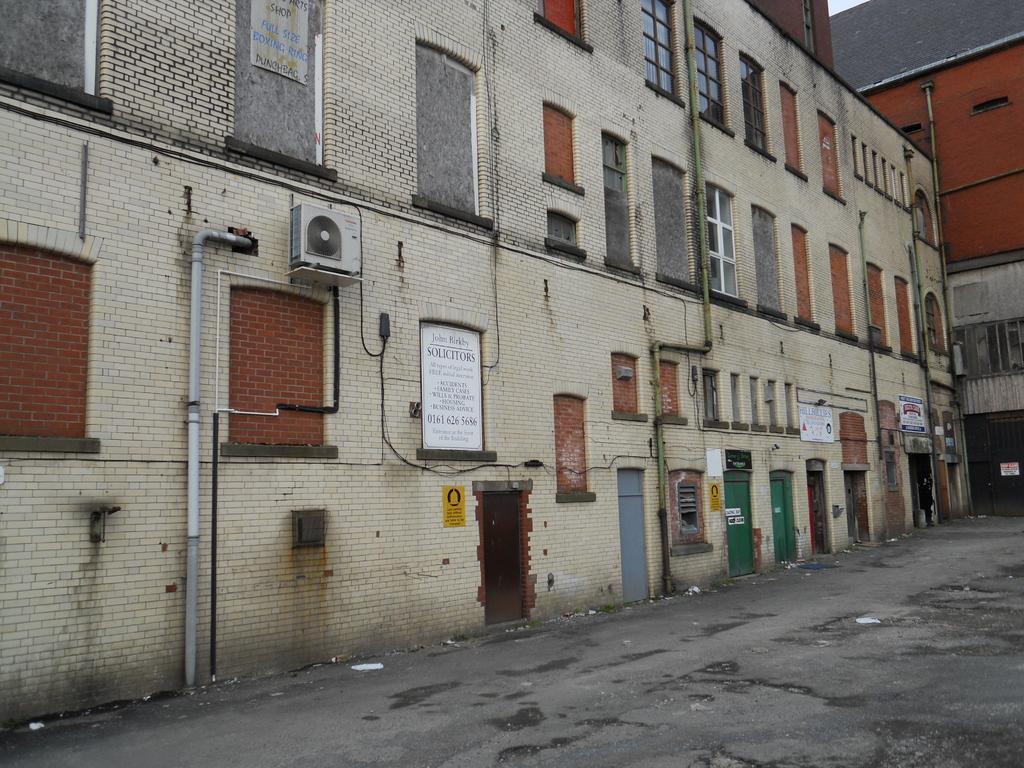In one or two sentences, can you explain what this image depicts? In this picture we can see so many buildings, in which we can see windows, boards, in front we can see the path. 